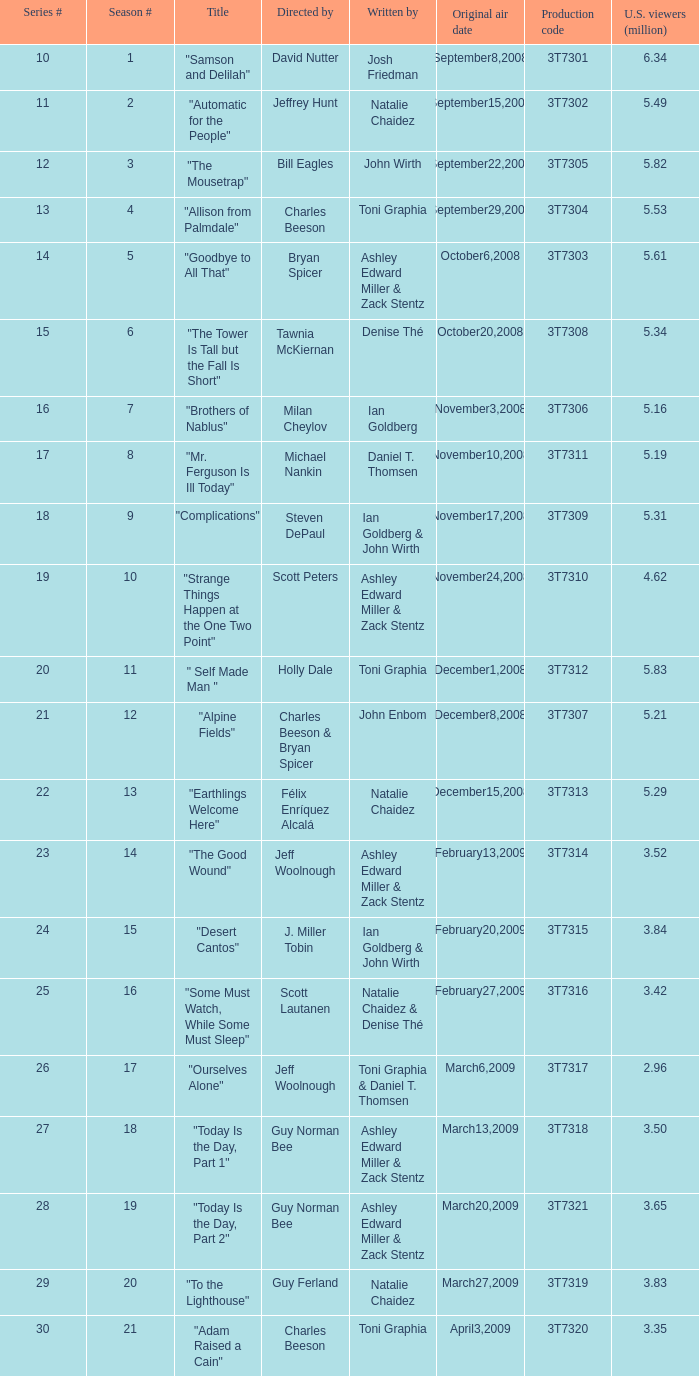Which episode number drew in 3.35 million viewers in the United States? 1.0. 